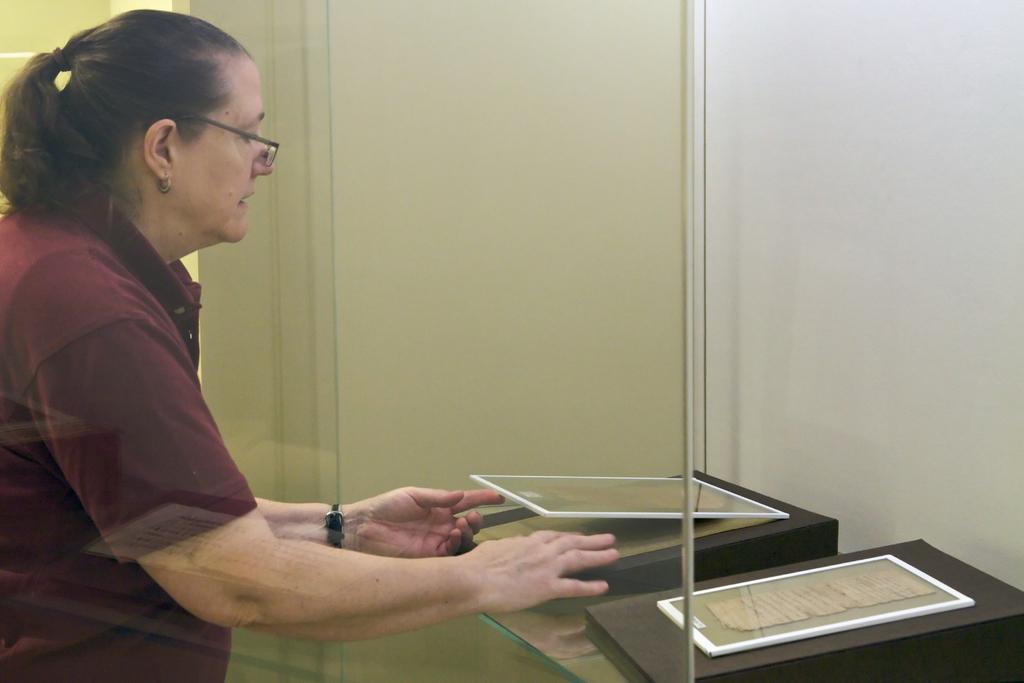Could you give a brief overview of what you see in this image? We can see a glass,behind this glass there is a woman standing and holding a frame. We can see frames and we can see wall. 